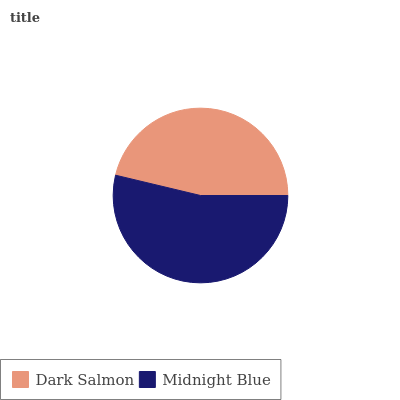Is Dark Salmon the minimum?
Answer yes or no. Yes. Is Midnight Blue the maximum?
Answer yes or no. Yes. Is Midnight Blue the minimum?
Answer yes or no. No. Is Midnight Blue greater than Dark Salmon?
Answer yes or no. Yes. Is Dark Salmon less than Midnight Blue?
Answer yes or no. Yes. Is Dark Salmon greater than Midnight Blue?
Answer yes or no. No. Is Midnight Blue less than Dark Salmon?
Answer yes or no. No. Is Midnight Blue the high median?
Answer yes or no. Yes. Is Dark Salmon the low median?
Answer yes or no. Yes. Is Dark Salmon the high median?
Answer yes or no. No. Is Midnight Blue the low median?
Answer yes or no. No. 